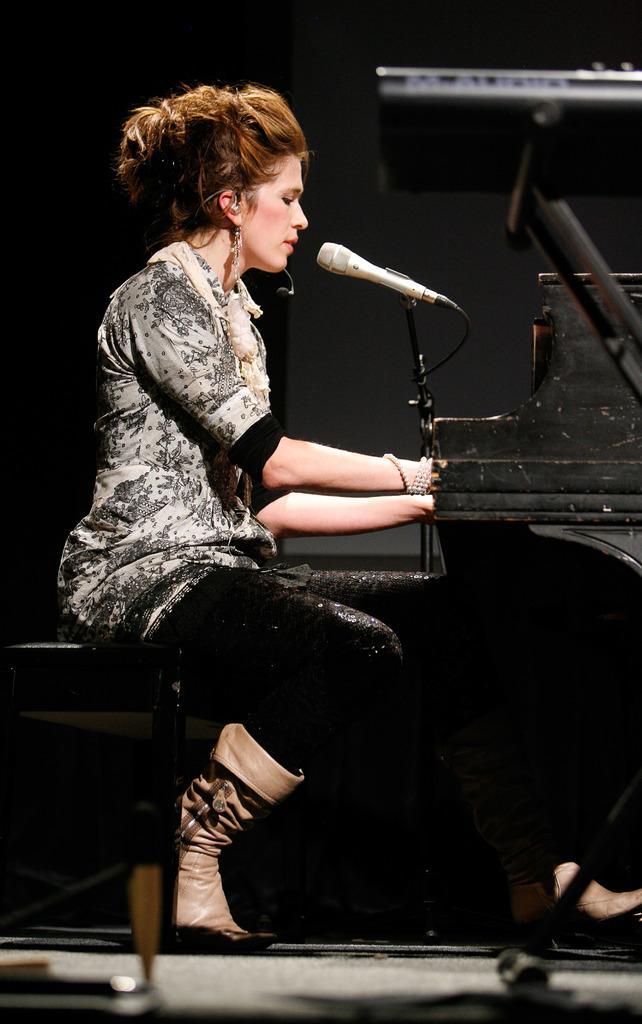Could you give a brief overview of what you see in this image? In this picture there is a lady who is sitting on the chair and there is a piano in front of the lady and a mic it seems to be she is singing in the mic. 